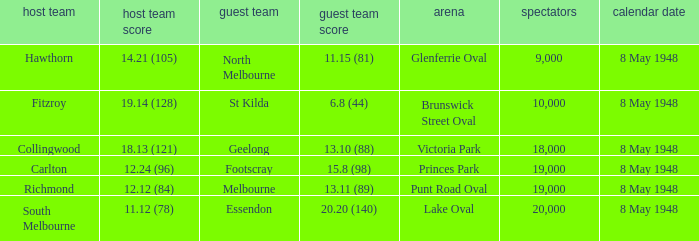Which away team has a home score of 14.21 (105)? North Melbourne. 